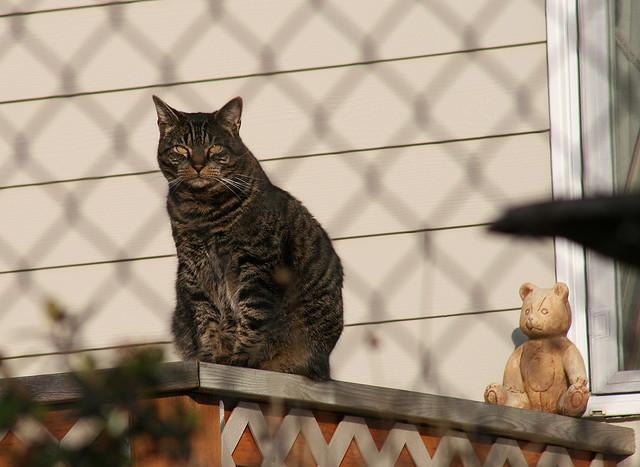Is the cat outside?
Short answer required. Yes. What is sitting behind the cat?
Write a very short answer. Teddy bear. What is between the camera and the cat?
Answer briefly. Fence. 